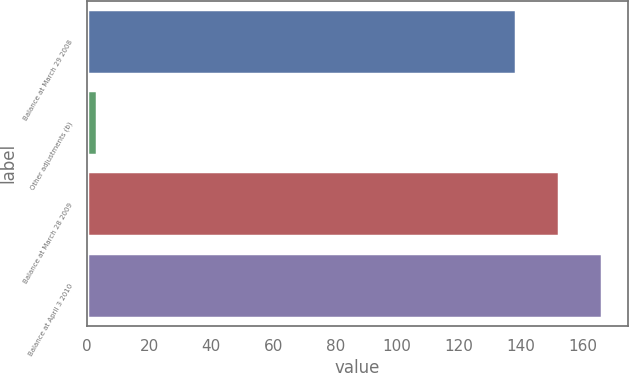<chart> <loc_0><loc_0><loc_500><loc_500><bar_chart><fcel>Balance at March 29 2008<fcel>Other adjustments (b)<fcel>Balance at March 28 2009<fcel>Balance at April 3 2010<nl><fcel>138.2<fcel>3.3<fcel>152.12<fcel>166.04<nl></chart> 